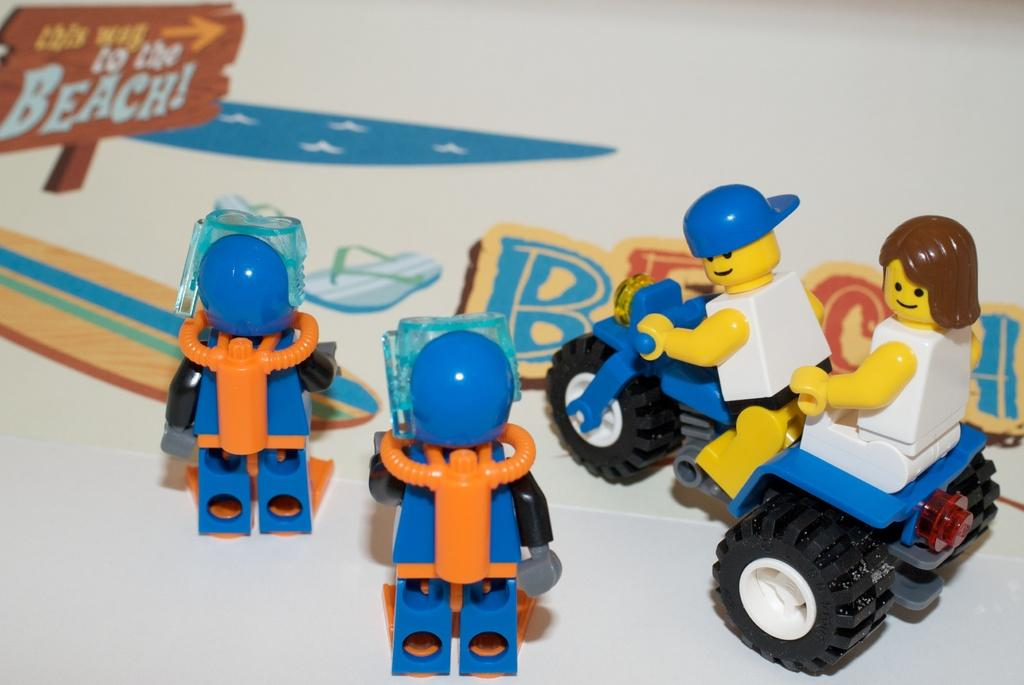What is located in the center of the image? There are toys in the center of the image. Where are the toys placed in the image? The toys are on a poster. What type of kitty can be seen playing with the toys on the poster in the image? There is no kitty present in the image, and therefore no such activity can be observed. 